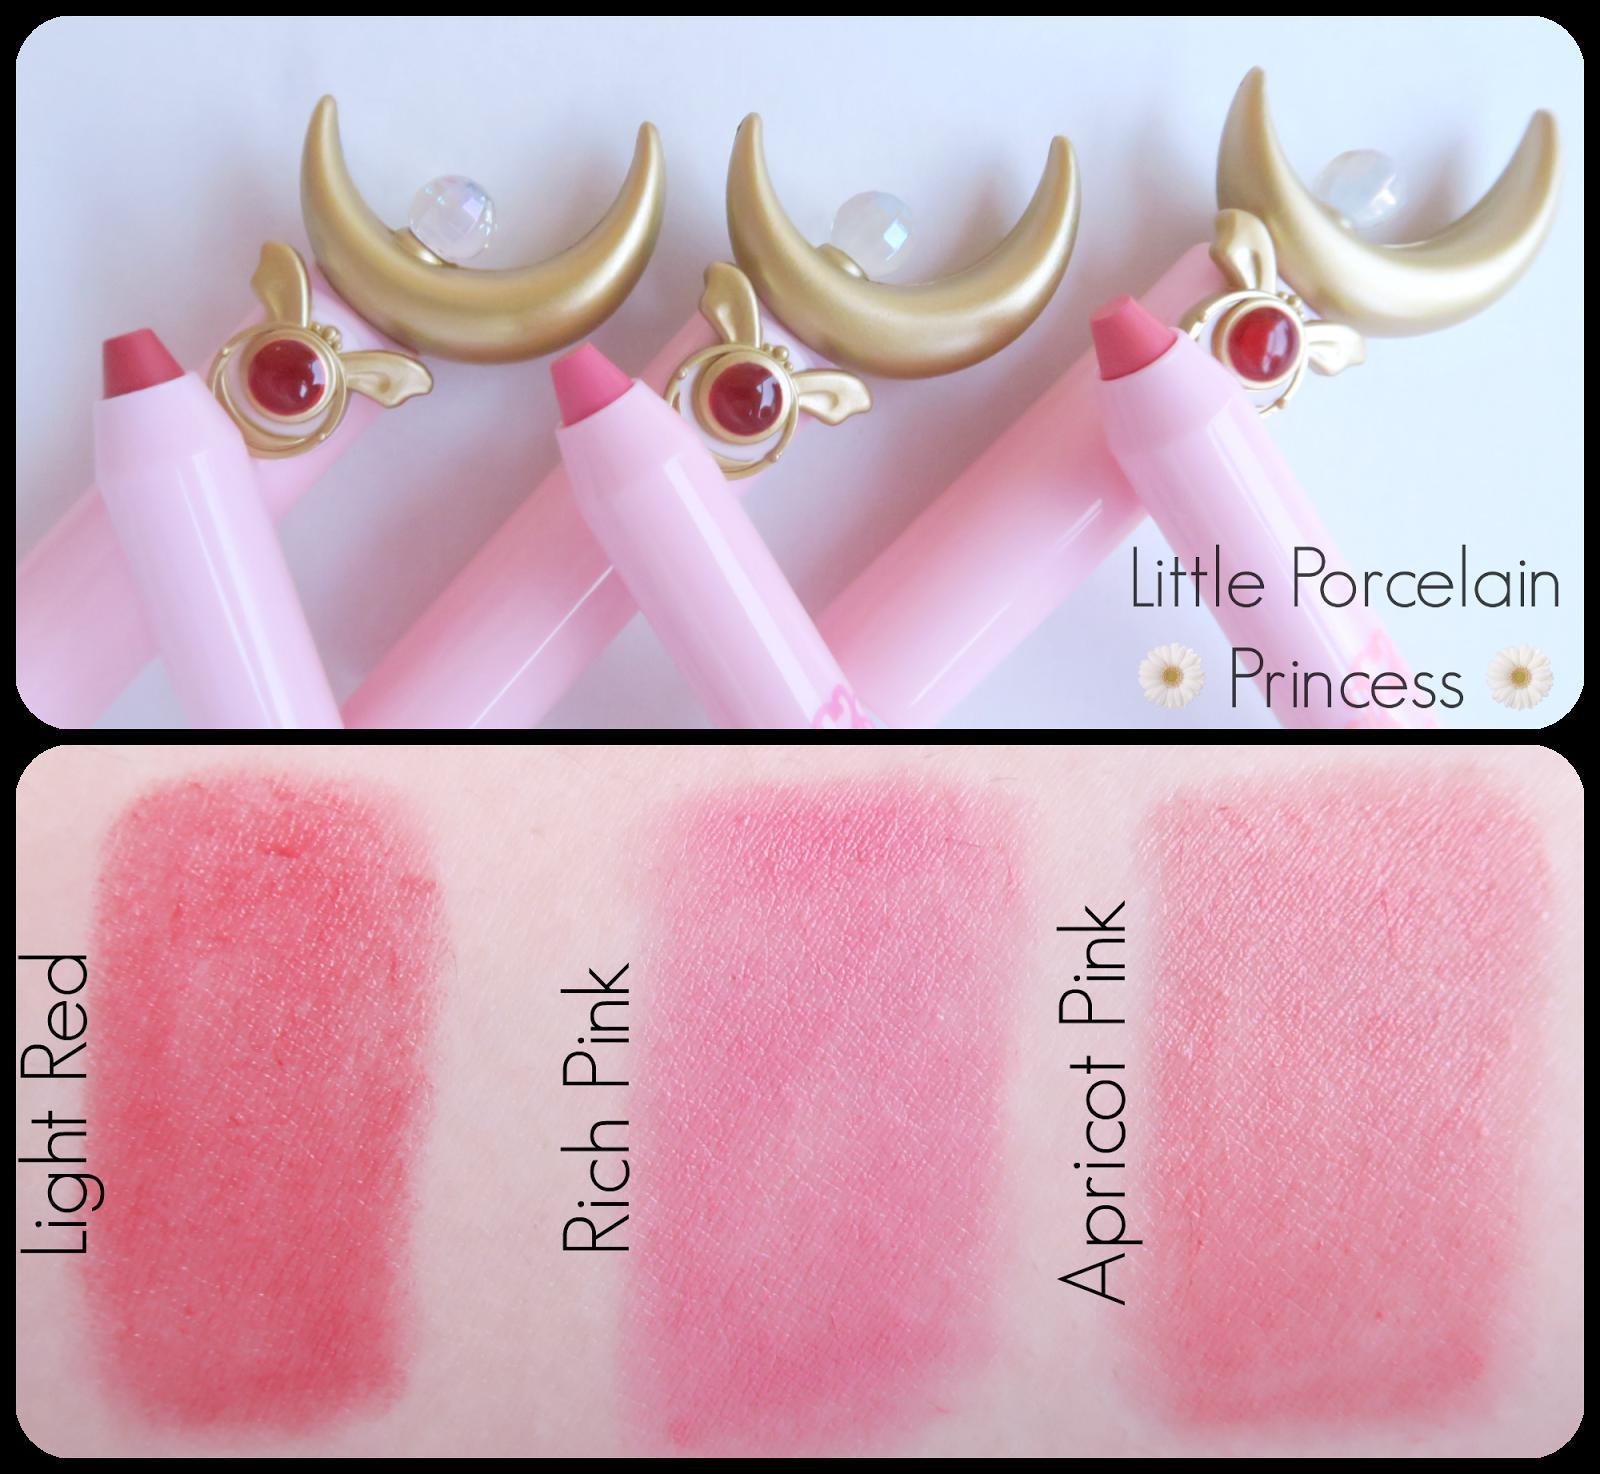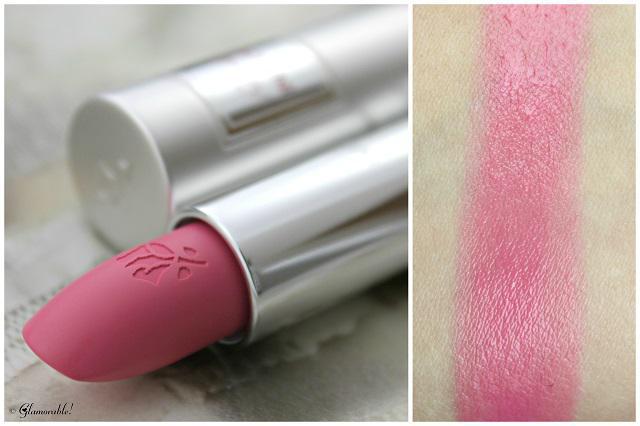The first image is the image on the left, the second image is the image on the right. Given the left and right images, does the statement "At least two pairs of lips are visible." hold true? Answer yes or no. No. The first image is the image on the left, the second image is the image on the right. Assess this claim about the two images: "There are lips in one of the images.". Correct or not? Answer yes or no. No. 